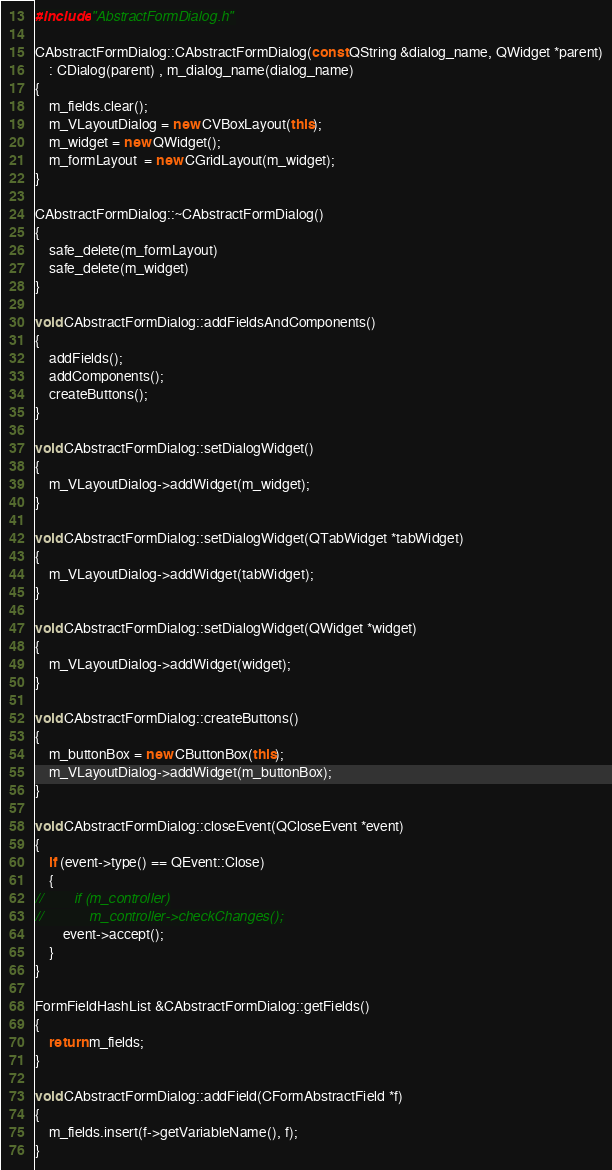<code> <loc_0><loc_0><loc_500><loc_500><_C++_>#include "AbstractFormDialog.h"

CAbstractFormDialog::CAbstractFormDialog(const QString &dialog_name, QWidget *parent)
    : CDialog(parent) , m_dialog_name(dialog_name)
{
    m_fields.clear();
    m_VLayoutDialog = new CVBoxLayout(this);
    m_widget = new QWidget();
    m_formLayout  = new CGridLayout(m_widget);   
}

CAbstractFormDialog::~CAbstractFormDialog()
{
    safe_delete(m_formLayout)
    safe_delete(m_widget)
}

void CAbstractFormDialog::addFieldsAndComponents()
{
    addFields();
    addComponents();
    createButtons();
}

void CAbstractFormDialog::setDialogWidget()
{
    m_VLayoutDialog->addWidget(m_widget);
}

void CAbstractFormDialog::setDialogWidget(QTabWidget *tabWidget)
{
    m_VLayoutDialog->addWidget(tabWidget);
}

void CAbstractFormDialog::setDialogWidget(QWidget *widget)
{
    m_VLayoutDialog->addWidget(widget);
}

void CAbstractFormDialog::createButtons()
{
    m_buttonBox = new CButtonBox(this);
    m_VLayoutDialog->addWidget(m_buttonBox);
}

void CAbstractFormDialog::closeEvent(QCloseEvent *event)
{
    if (event->type() == QEvent::Close)
    {
//        if (m_controller)
//            m_controller->checkChanges();
        event->accept();
    }
}

FormFieldHashList &CAbstractFormDialog::getFields()
{
    return m_fields;
}

void CAbstractFormDialog::addField(CFormAbstractField *f)
{
    m_fields.insert(f->getVariableName(), f);
}
</code> 